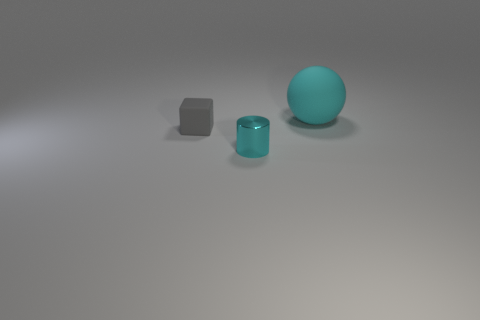Add 2 matte balls. How many objects exist? 5 Subtract all spheres. How many objects are left? 2 Add 2 shiny things. How many shiny things are left? 3 Add 2 metallic things. How many metallic things exist? 3 Subtract 0 purple blocks. How many objects are left? 3 Subtract all tiny gray matte cylinders. Subtract all matte things. How many objects are left? 1 